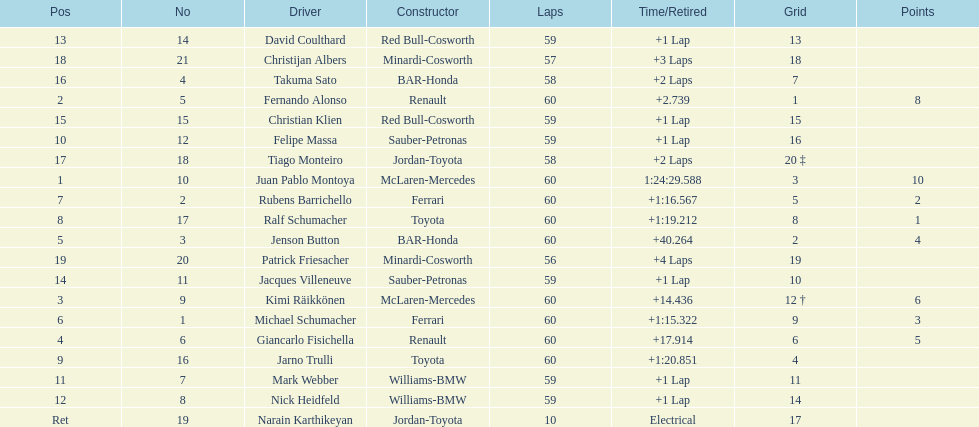Is there a points difference between the 9th position and 19th position on the list? No. 